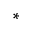Convert formula to latex. <formula><loc_0><loc_0><loc_500><loc_500>^ { \ast }</formula> 